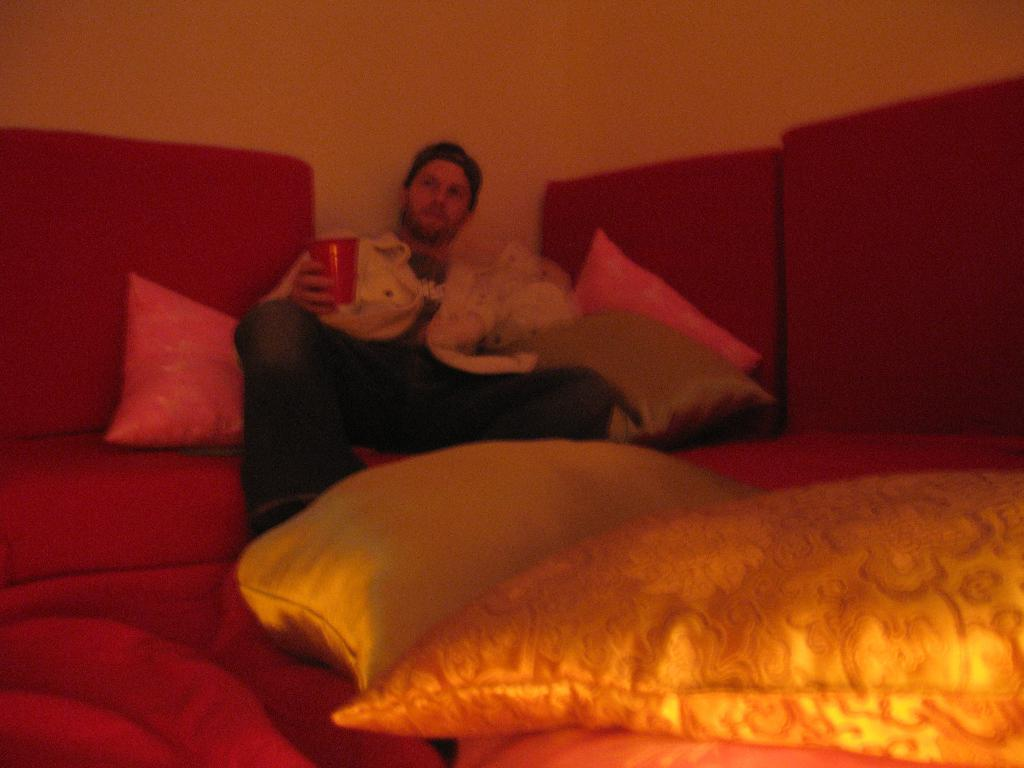Who is present in the image? There is a man in the image. What is the man doing in the image? The man is sitting on a sofa. What is the man holding in the image? The man is holding a glass. What can be seen behind the man in the image? There is a wall in the image. What type of plastic jelly can be seen in the man's brain in the image? There is no indication of the man's brain or any plastic jelly in the image. 